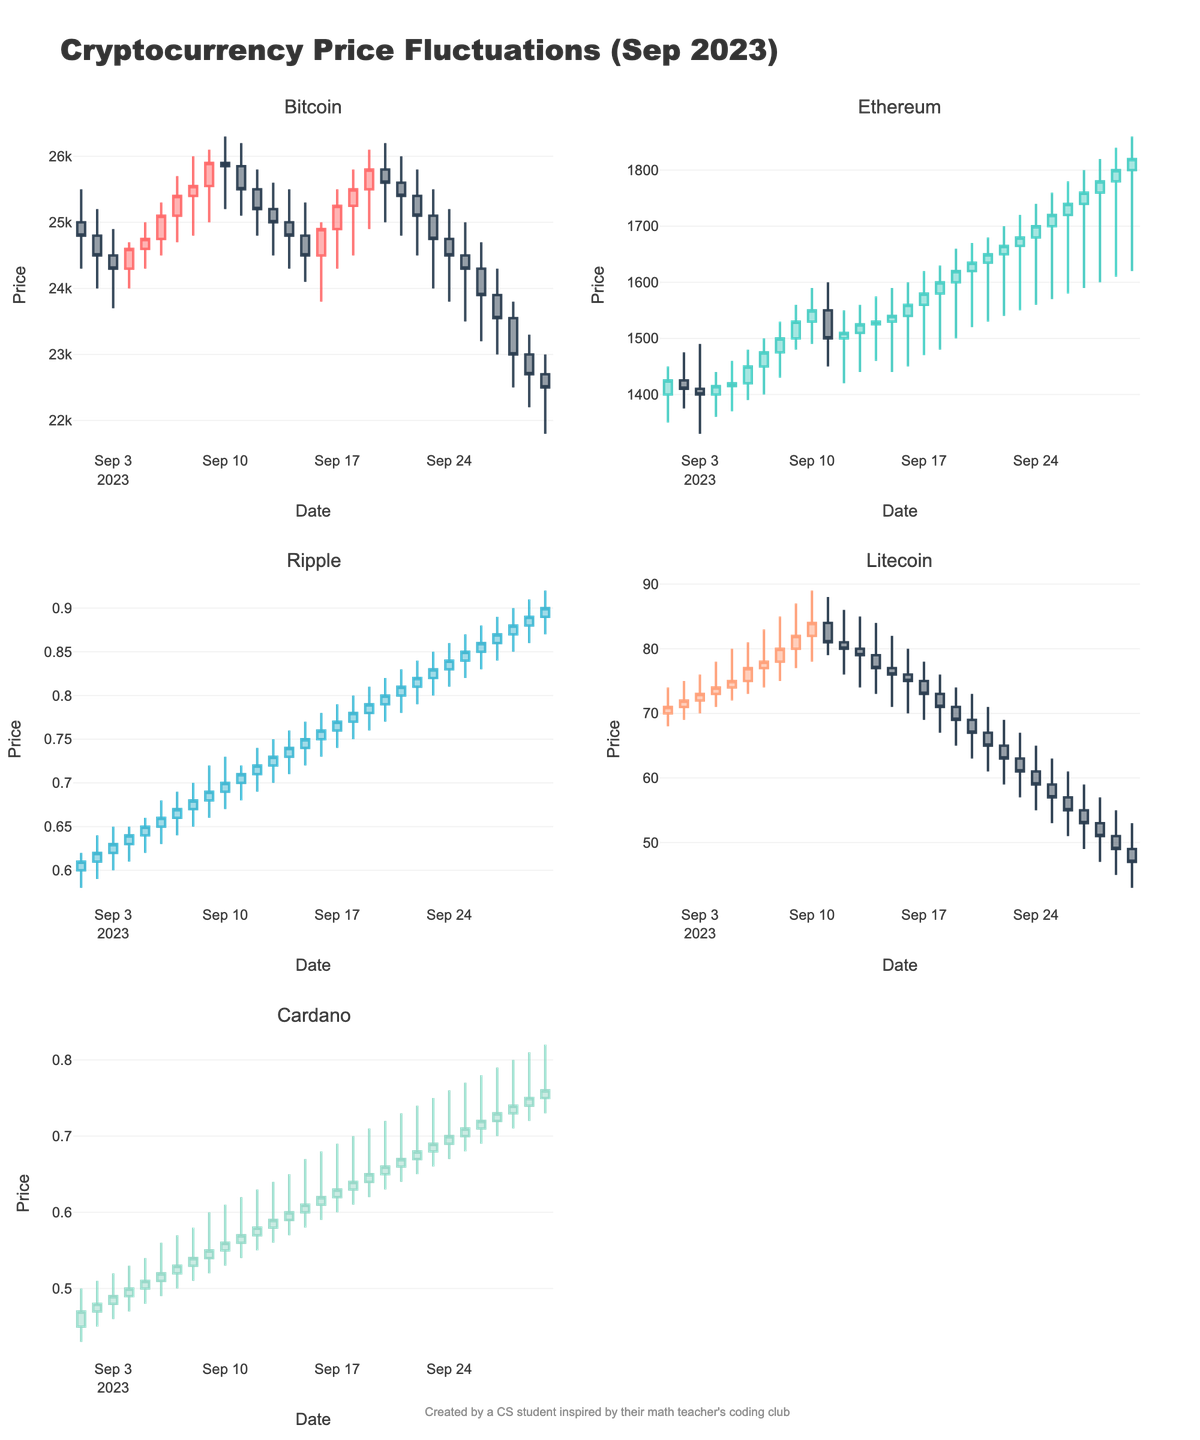What is the cryptocurrency with the highest closing price on September 7th? The plot shows five cryptocurrencies with their price fluctuations throughout September. For September 7th, check the closing prices indicated by the top of the filled rectangles. Bitcoin closes at 25,400, Ethereum at 1,475, Ripple at 0.67, Litecoin at 78, and Cardano at 0.53. Bitcoin has the highest closing price.
Answer: Bitcoin On September 15th, did Ethereum's closing price increase or decrease compared to the previous day? Examine Ethereum's candlestick for September 14th and 15th. On September 14th, the closing price was 1,530, and on September 15th, it was 1,540. Since 1,540 is higher than 1,530, Ethereum's price increased.
Answer: Increased What is the range of Litecoin's price on September 6th? Find the candlestick for Litecoin on September 6th. The highest point is 81 and the lowest point is 73. Subtracting the lowest point from the highest gives the range: 81 - 73 = 8.
Answer: 8 Which cryptocurrency had the largest price drop from open to close on September 30th? Compare the open and close prices for each cryptocurrency on September 30th. Bitcoin: 22,700 -> 22,500, Ethereum: 1,800 -> 1,820, Ripple: 0.89 -> 0.90, Litecoin: 49 -> 47, Cardano: 0.75 -> 0.76. Bitcoin has the largest drop: 22700 - 22500 = 200.
Answer: Bitcoin What was the trend of Cardano's prices during the last week of September? Check the candlesticks for Cardano between September 24th and September 30th. Observe the sequence of opening, closing, high, and low prices. Cardano shows a general decrease in price from 24500 on September 24th to 22500 on September 30th.
Answer: Decreasing 